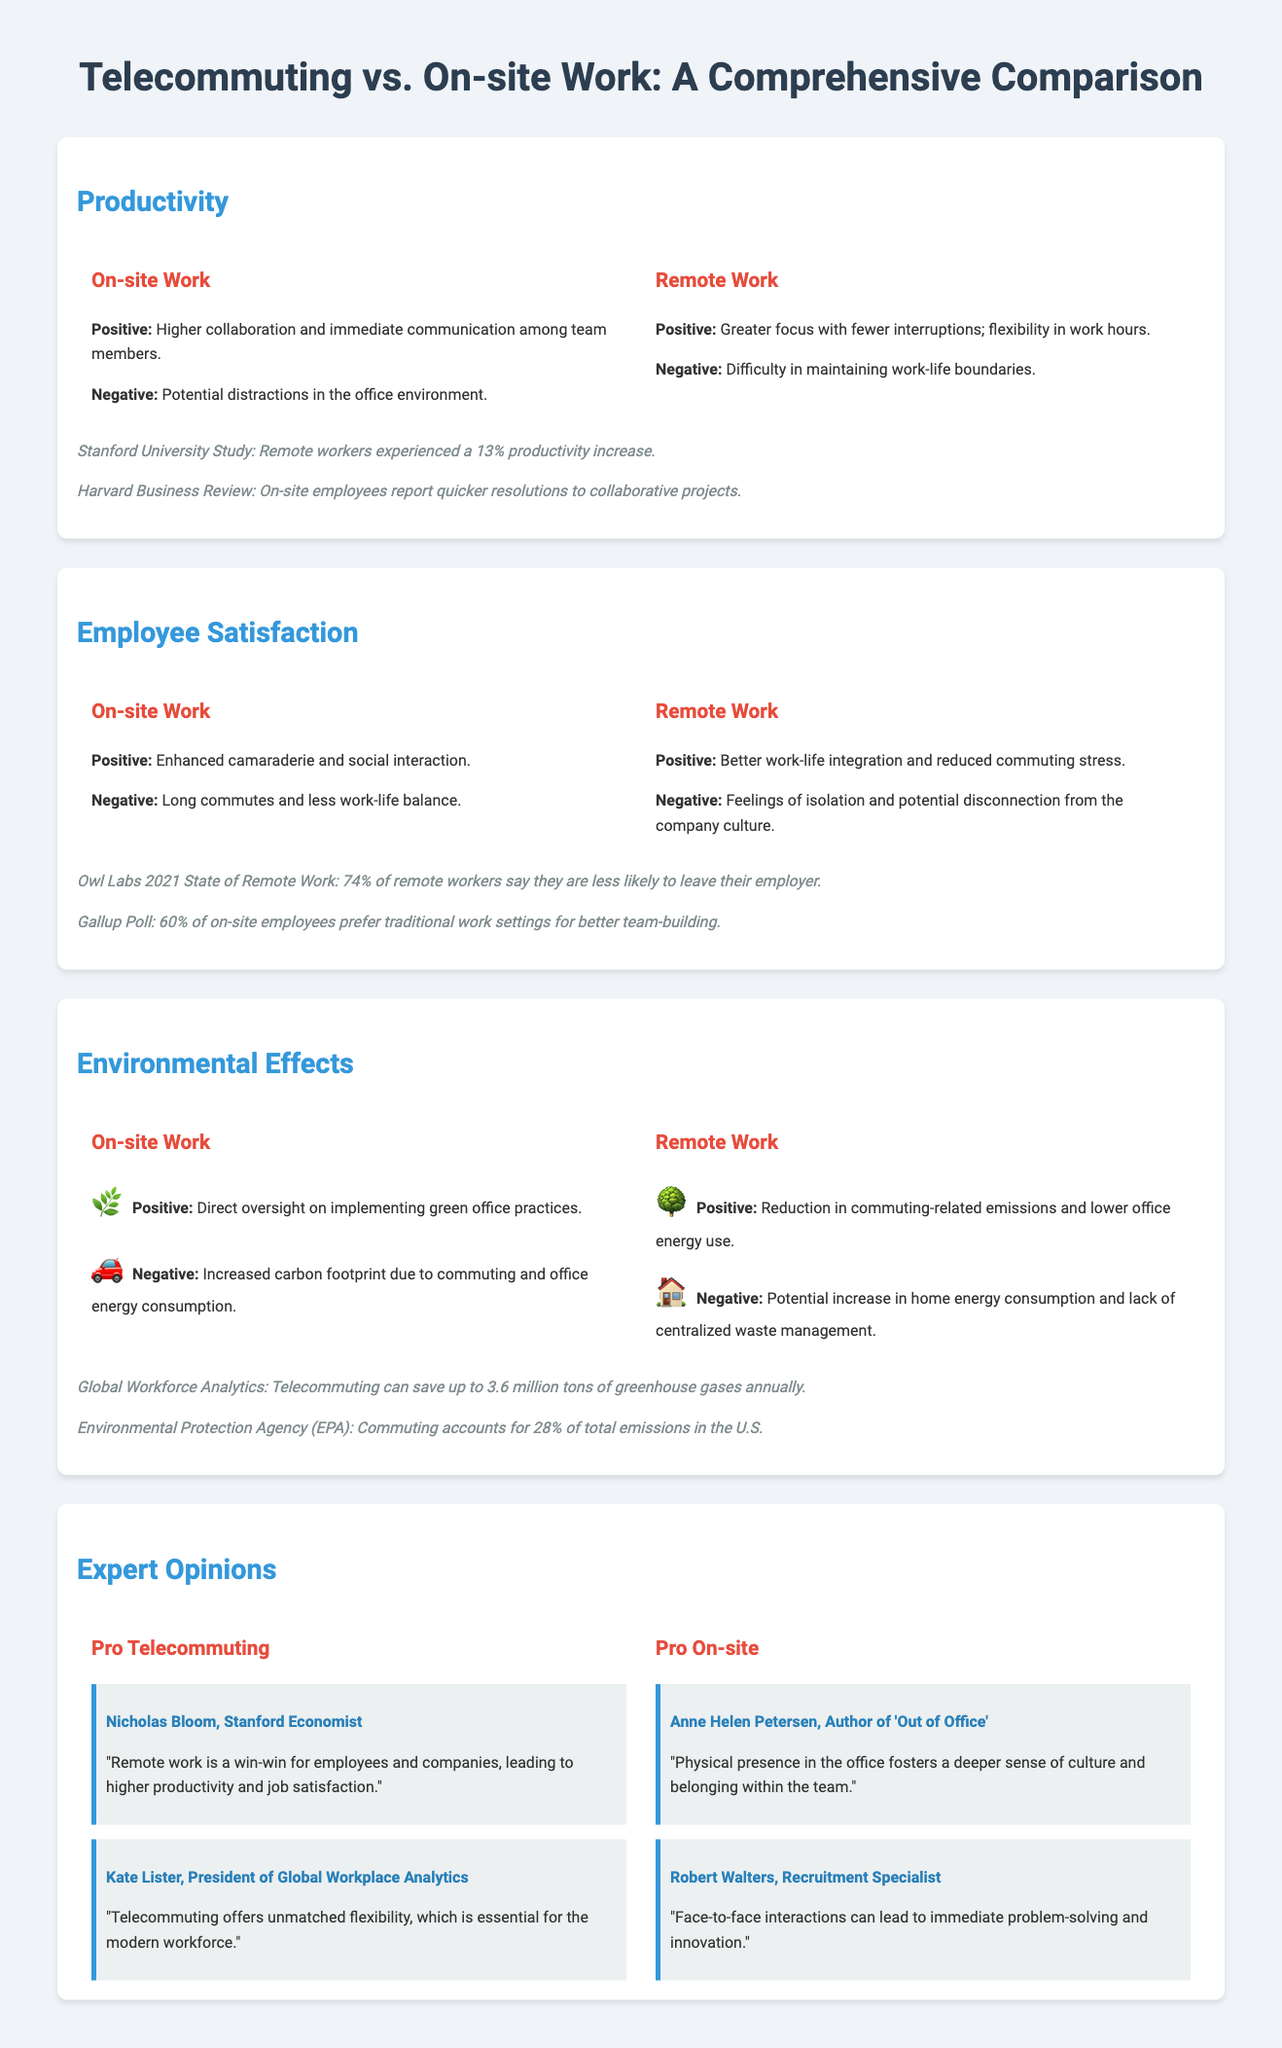What percentage of remote workers say they are less likely to leave their employer? The document states that 74% of remote workers say they are less likely to leave their employer according to the Owl Labs 2021 State of Remote Work.
Answer: 74% What is a positive effect of on-site work on productivity? The document notes that a positive effect of on-site work on productivity is higher collaboration and immediate communication among team members.
Answer: Higher collaboration What is a negative effect of remote work related to employee satisfaction? The document indicates that a negative effect of remote work is feelings of isolation and potential disconnection from the company culture.
Answer: Feelings of isolation Who is an expert that supports telecommuting? The document mentions Nicholas Bloom, a Stanford economist, who supports telecommuting.
Answer: Nicholas Bloom What is the potential environmental negative impact of remote work? The document indicates that a potential negative impact of remote work is an increase in home energy consumption and lack of centralized waste management.
Answer: Increase in home energy consumption What study reported a productivity increase for remote workers? The document references a Stanford University Study where remote workers experienced a 13% productivity increase.
Answer: Stanford University Study What percentage of on-site employees prefer traditional work settings for better team-building? According to the document, 60% of on-site employees prefer traditional work settings for better team-building as indicated by a Gallup Poll.
Answer: 60% What is a positive environmental effect of remote work? The document states that a positive environmental effect of remote work is the reduction in commuting-related emissions and lower office energy use.
Answer: Reduction in commuting-related emissions What does Anne Helen Petersen say about physical presence in the office? The document quotes Anne Helen Petersen stating that physical presence in the office fosters a deeper sense of culture and belonging within the team.
Answer: Fosters a deeper sense of culture 